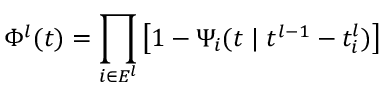<formula> <loc_0><loc_0><loc_500><loc_500>\Phi ^ { l } ( t ) = \prod _ { i \in E ^ { l } } \left [ 1 - \Psi _ { i } ( t { \, | \, } t ^ { l - 1 } - t _ { i } ^ { l } ) \right ]</formula> 